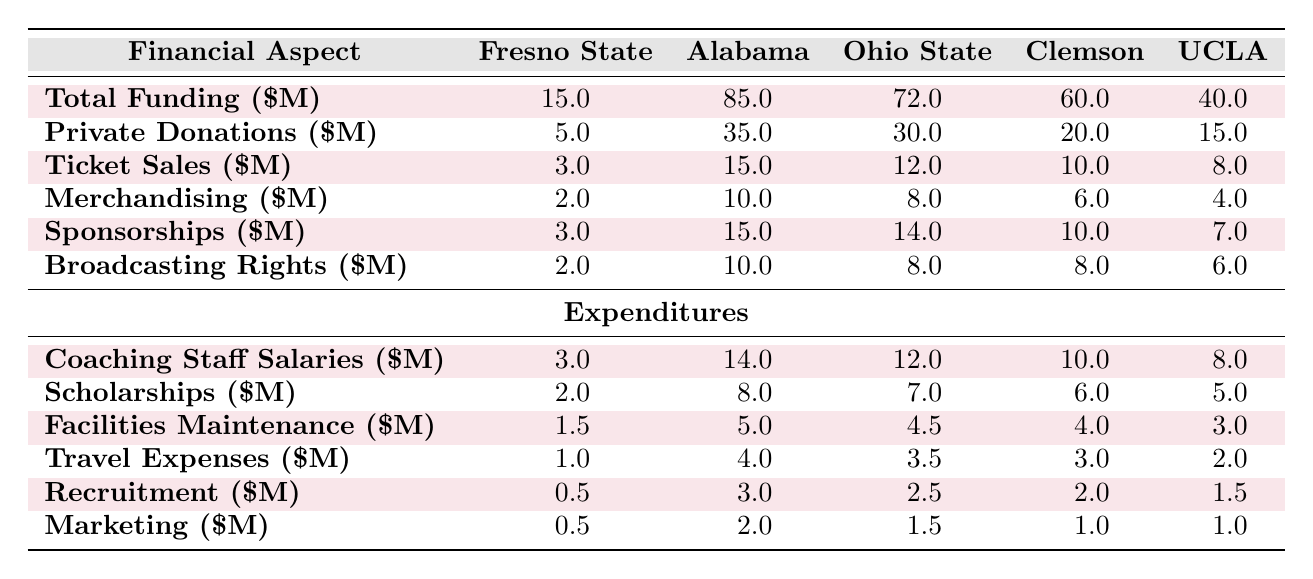What is the total funding for the Fresno State football program? The table includes a row for "Total Funding" under the Fresno State column, which shows the value as 15.0 million dollars.
Answer: 15.0 million How much does Alabama have in private donations? The table states that Alabama has private donations of 35.0 million dollars in the corresponding row under the Alabama column.
Answer: 35.0 million Which team has the highest ticket sales? By examining the "Ticket Sales" row, Alabama shows the highest value of 15.0 million dollars, more than any other team in the comparison.
Answer: Alabama What is the difference in total funding between Fresno State and Clemson? The total funding for Fresno State is 15.0 million dollars, and for Clemson, it is 60.0 million dollars. The difference is calculated as 60.0 - 15.0 = 45.0 million dollars.
Answer: 45.0 million Do Fresno State's coaching staff salaries exceed those of UCLA? The coaching staff salaries for Fresno State are 3.0 million dollars, while for UCLA, they are 8.0 million dollars. Since 3.0 is less than 8.0, the statement is false.
Answer: No What is the average amount spent on scholarships by the teams compared? The scholarship amounts are 2.0 (Fresno State), 8.0 (Alabama), 7.0 (Ohio State), 6.0 (Clemson), and 5.0 (UCLA). First, summing these gives 2.0 + 8.0 + 7.0 + 6.0 + 5.0 = 28.0 million dollars. Then, dividing by the number of teams (5), the average is 28.0 / 5 = 5.6 million dollars.
Answer: 5.6 million How much more does Ohio State spend on recruitment compared to Fresno State? The recruitment expenditures are 2.5 million for Ohio State and 0.5 million for Fresno State. The difference is calculated as 2.5 - 0.5 = 2.0 million dollars.
Answer: 2.0 million Is the total funding for Fresno State more than the total funding of UCLA? Fresno State's total funding is 15.0 million, while UCLA's is 40.0 million. Since 15.0 is less than 40.0, the statement is false.
Answer: No What is the total amount spent on travel expenses by all teams compared? The travel expenses for each team are 1.0 (Fresno State), 4.0 (Alabama), 3.5 (Ohio State), 3.0 (Clemson), and 2.0 (UCLA). Summing them gives 1.0 + 4.0 + 3.5 + 3.0 + 2.0 = 13.5 million dollars.
Answer: 13.5 million 